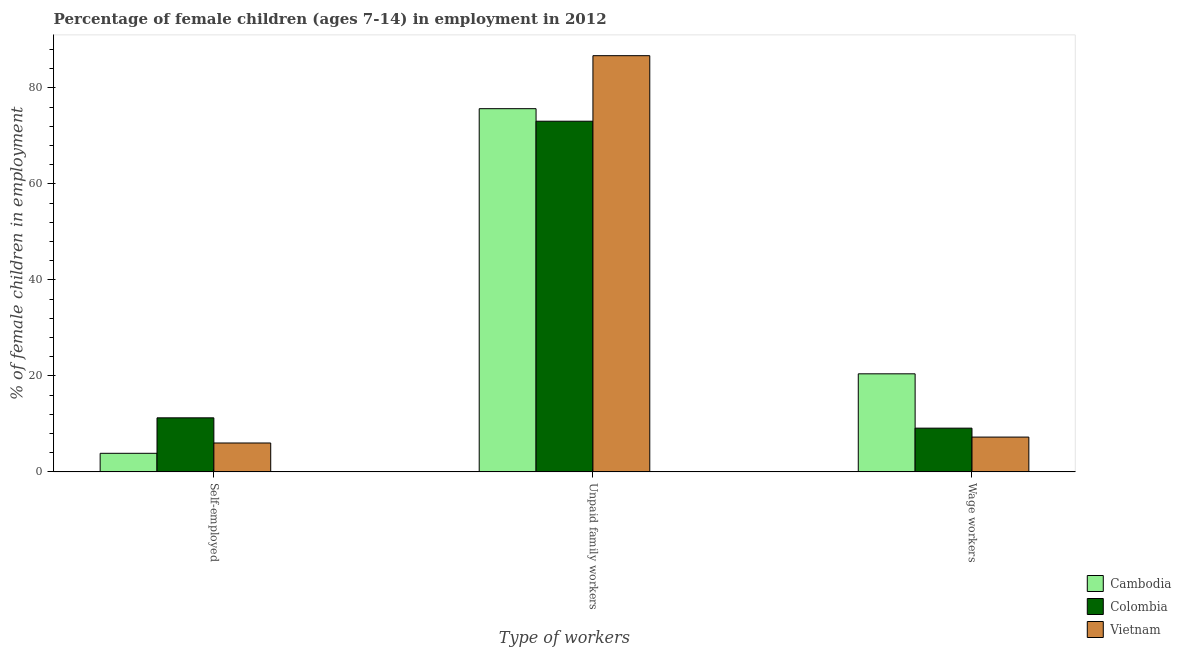Are the number of bars on each tick of the X-axis equal?
Your answer should be compact. Yes. How many bars are there on the 1st tick from the right?
Your answer should be very brief. 3. What is the label of the 2nd group of bars from the left?
Your answer should be compact. Unpaid family workers. What is the percentage of self employed children in Vietnam?
Provide a succinct answer. 6.03. Across all countries, what is the maximum percentage of self employed children?
Your response must be concise. 11.27. Across all countries, what is the minimum percentage of children employed as unpaid family workers?
Provide a short and direct response. 73.06. In which country was the percentage of children employed as wage workers maximum?
Your answer should be very brief. Cambodia. In which country was the percentage of children employed as wage workers minimum?
Keep it short and to the point. Vietnam. What is the total percentage of self employed children in the graph?
Offer a very short reply. 21.18. What is the difference between the percentage of children employed as unpaid family workers in Colombia and that in Cambodia?
Your answer should be compact. -2.61. What is the difference between the percentage of self employed children in Colombia and the percentage of children employed as wage workers in Cambodia?
Give a very brief answer. -9.17. What is the average percentage of self employed children per country?
Your answer should be compact. 7.06. What is the difference between the percentage of children employed as unpaid family workers and percentage of self employed children in Vietnam?
Your answer should be compact. 80.68. What is the ratio of the percentage of self employed children in Vietnam to that in Cambodia?
Your answer should be compact. 1.55. What is the difference between the highest and the second highest percentage of children employed as wage workers?
Offer a terse response. 11.32. What is the difference between the highest and the lowest percentage of children employed as wage workers?
Your answer should be compact. 13.18. In how many countries, is the percentage of self employed children greater than the average percentage of self employed children taken over all countries?
Provide a succinct answer. 1. What does the 1st bar from the left in Unpaid family workers represents?
Ensure brevity in your answer.  Cambodia. What does the 3rd bar from the right in Self-employed represents?
Offer a terse response. Cambodia. Does the graph contain grids?
Your response must be concise. No. Where does the legend appear in the graph?
Give a very brief answer. Bottom right. How many legend labels are there?
Offer a very short reply. 3. How are the legend labels stacked?
Provide a short and direct response. Vertical. What is the title of the graph?
Your answer should be very brief. Percentage of female children (ages 7-14) in employment in 2012. What is the label or title of the X-axis?
Ensure brevity in your answer.  Type of workers. What is the label or title of the Y-axis?
Make the answer very short. % of female children in employment. What is the % of female children in employment of Cambodia in Self-employed?
Your answer should be compact. 3.88. What is the % of female children in employment of Colombia in Self-employed?
Your answer should be compact. 11.27. What is the % of female children in employment in Vietnam in Self-employed?
Your answer should be compact. 6.03. What is the % of female children in employment of Cambodia in Unpaid family workers?
Offer a very short reply. 75.67. What is the % of female children in employment of Colombia in Unpaid family workers?
Offer a very short reply. 73.06. What is the % of female children in employment in Vietnam in Unpaid family workers?
Offer a terse response. 86.71. What is the % of female children in employment of Cambodia in Wage workers?
Ensure brevity in your answer.  20.44. What is the % of female children in employment in Colombia in Wage workers?
Give a very brief answer. 9.12. What is the % of female children in employment of Vietnam in Wage workers?
Make the answer very short. 7.26. Across all Type of workers, what is the maximum % of female children in employment of Cambodia?
Your answer should be very brief. 75.67. Across all Type of workers, what is the maximum % of female children in employment of Colombia?
Keep it short and to the point. 73.06. Across all Type of workers, what is the maximum % of female children in employment of Vietnam?
Your answer should be very brief. 86.71. Across all Type of workers, what is the minimum % of female children in employment in Cambodia?
Your answer should be compact. 3.88. Across all Type of workers, what is the minimum % of female children in employment of Colombia?
Your answer should be very brief. 9.12. Across all Type of workers, what is the minimum % of female children in employment of Vietnam?
Keep it short and to the point. 6.03. What is the total % of female children in employment of Cambodia in the graph?
Keep it short and to the point. 99.99. What is the total % of female children in employment of Colombia in the graph?
Provide a short and direct response. 93.45. What is the total % of female children in employment in Vietnam in the graph?
Make the answer very short. 100. What is the difference between the % of female children in employment in Cambodia in Self-employed and that in Unpaid family workers?
Your answer should be very brief. -71.79. What is the difference between the % of female children in employment of Colombia in Self-employed and that in Unpaid family workers?
Give a very brief answer. -61.79. What is the difference between the % of female children in employment of Vietnam in Self-employed and that in Unpaid family workers?
Ensure brevity in your answer.  -80.68. What is the difference between the % of female children in employment in Cambodia in Self-employed and that in Wage workers?
Ensure brevity in your answer.  -16.56. What is the difference between the % of female children in employment of Colombia in Self-employed and that in Wage workers?
Your answer should be very brief. 2.15. What is the difference between the % of female children in employment of Vietnam in Self-employed and that in Wage workers?
Offer a terse response. -1.23. What is the difference between the % of female children in employment of Cambodia in Unpaid family workers and that in Wage workers?
Your answer should be very brief. 55.23. What is the difference between the % of female children in employment of Colombia in Unpaid family workers and that in Wage workers?
Provide a succinct answer. 63.94. What is the difference between the % of female children in employment in Vietnam in Unpaid family workers and that in Wage workers?
Offer a very short reply. 79.45. What is the difference between the % of female children in employment in Cambodia in Self-employed and the % of female children in employment in Colombia in Unpaid family workers?
Ensure brevity in your answer.  -69.18. What is the difference between the % of female children in employment in Cambodia in Self-employed and the % of female children in employment in Vietnam in Unpaid family workers?
Offer a terse response. -82.83. What is the difference between the % of female children in employment of Colombia in Self-employed and the % of female children in employment of Vietnam in Unpaid family workers?
Offer a terse response. -75.44. What is the difference between the % of female children in employment of Cambodia in Self-employed and the % of female children in employment of Colombia in Wage workers?
Provide a short and direct response. -5.24. What is the difference between the % of female children in employment in Cambodia in Self-employed and the % of female children in employment in Vietnam in Wage workers?
Offer a very short reply. -3.38. What is the difference between the % of female children in employment of Colombia in Self-employed and the % of female children in employment of Vietnam in Wage workers?
Ensure brevity in your answer.  4.01. What is the difference between the % of female children in employment in Cambodia in Unpaid family workers and the % of female children in employment in Colombia in Wage workers?
Give a very brief answer. 66.55. What is the difference between the % of female children in employment in Cambodia in Unpaid family workers and the % of female children in employment in Vietnam in Wage workers?
Keep it short and to the point. 68.41. What is the difference between the % of female children in employment of Colombia in Unpaid family workers and the % of female children in employment of Vietnam in Wage workers?
Your response must be concise. 65.8. What is the average % of female children in employment of Cambodia per Type of workers?
Your answer should be compact. 33.33. What is the average % of female children in employment of Colombia per Type of workers?
Make the answer very short. 31.15. What is the average % of female children in employment of Vietnam per Type of workers?
Make the answer very short. 33.33. What is the difference between the % of female children in employment of Cambodia and % of female children in employment of Colombia in Self-employed?
Make the answer very short. -7.39. What is the difference between the % of female children in employment in Cambodia and % of female children in employment in Vietnam in Self-employed?
Provide a succinct answer. -2.15. What is the difference between the % of female children in employment of Colombia and % of female children in employment of Vietnam in Self-employed?
Keep it short and to the point. 5.24. What is the difference between the % of female children in employment in Cambodia and % of female children in employment in Colombia in Unpaid family workers?
Provide a succinct answer. 2.61. What is the difference between the % of female children in employment of Cambodia and % of female children in employment of Vietnam in Unpaid family workers?
Make the answer very short. -11.04. What is the difference between the % of female children in employment of Colombia and % of female children in employment of Vietnam in Unpaid family workers?
Keep it short and to the point. -13.65. What is the difference between the % of female children in employment in Cambodia and % of female children in employment in Colombia in Wage workers?
Ensure brevity in your answer.  11.32. What is the difference between the % of female children in employment in Cambodia and % of female children in employment in Vietnam in Wage workers?
Your answer should be compact. 13.18. What is the difference between the % of female children in employment of Colombia and % of female children in employment of Vietnam in Wage workers?
Provide a short and direct response. 1.86. What is the ratio of the % of female children in employment in Cambodia in Self-employed to that in Unpaid family workers?
Your response must be concise. 0.05. What is the ratio of the % of female children in employment of Colombia in Self-employed to that in Unpaid family workers?
Offer a terse response. 0.15. What is the ratio of the % of female children in employment of Vietnam in Self-employed to that in Unpaid family workers?
Offer a terse response. 0.07. What is the ratio of the % of female children in employment of Cambodia in Self-employed to that in Wage workers?
Your answer should be compact. 0.19. What is the ratio of the % of female children in employment in Colombia in Self-employed to that in Wage workers?
Your answer should be compact. 1.24. What is the ratio of the % of female children in employment in Vietnam in Self-employed to that in Wage workers?
Offer a very short reply. 0.83. What is the ratio of the % of female children in employment in Cambodia in Unpaid family workers to that in Wage workers?
Ensure brevity in your answer.  3.7. What is the ratio of the % of female children in employment in Colombia in Unpaid family workers to that in Wage workers?
Keep it short and to the point. 8.01. What is the ratio of the % of female children in employment in Vietnam in Unpaid family workers to that in Wage workers?
Your response must be concise. 11.94. What is the difference between the highest and the second highest % of female children in employment in Cambodia?
Ensure brevity in your answer.  55.23. What is the difference between the highest and the second highest % of female children in employment in Colombia?
Ensure brevity in your answer.  61.79. What is the difference between the highest and the second highest % of female children in employment in Vietnam?
Keep it short and to the point. 79.45. What is the difference between the highest and the lowest % of female children in employment of Cambodia?
Your response must be concise. 71.79. What is the difference between the highest and the lowest % of female children in employment in Colombia?
Your answer should be very brief. 63.94. What is the difference between the highest and the lowest % of female children in employment in Vietnam?
Provide a succinct answer. 80.68. 